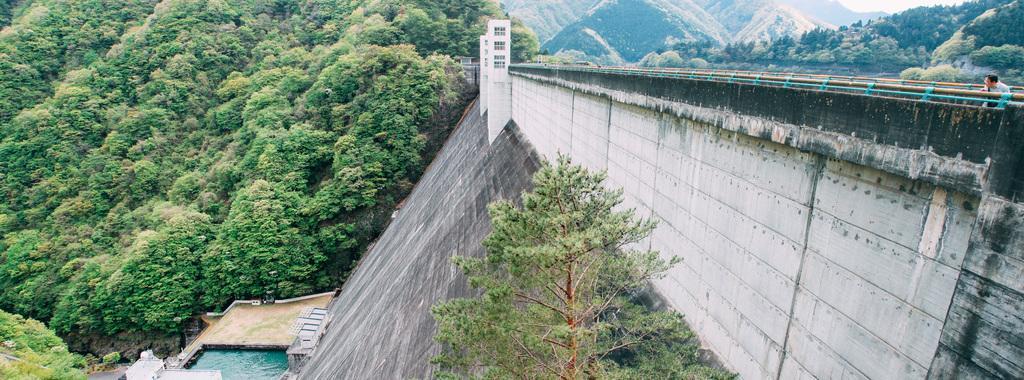Could you give a brief overview of what you see in this image? In this image we can see mountains, trees, water, slope, windows and rods. Backside of these roads we can see a person. 